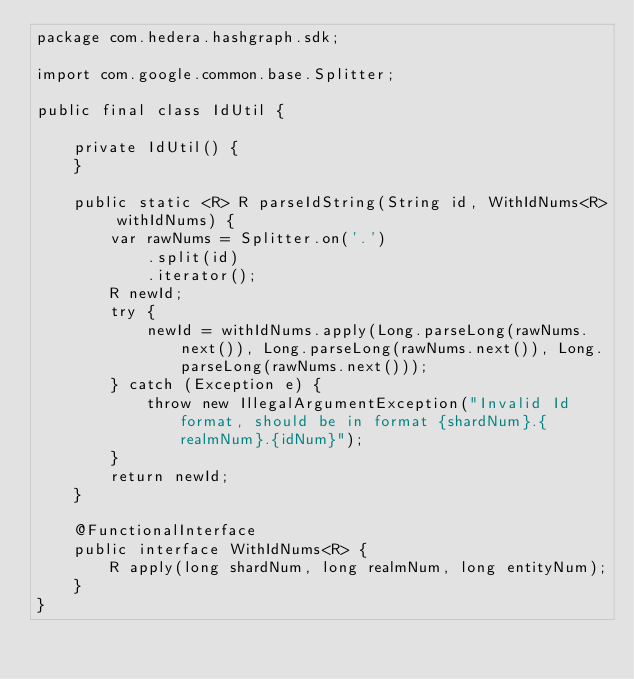Convert code to text. <code><loc_0><loc_0><loc_500><loc_500><_Java_>package com.hedera.hashgraph.sdk;

import com.google.common.base.Splitter;

public final class IdUtil {

    private IdUtil() {
    }

    public static <R> R parseIdString(String id, WithIdNums<R> withIdNums) {
        var rawNums = Splitter.on('.')
            .split(id)
            .iterator();
        R newId;
        try {
            newId = withIdNums.apply(Long.parseLong(rawNums.next()), Long.parseLong(rawNums.next()), Long.parseLong(rawNums.next()));
        } catch (Exception e) {
            throw new IllegalArgumentException("Invalid Id format, should be in format {shardNum}.{realmNum}.{idNum}");
        }
        return newId;
    }

    @FunctionalInterface
    public interface WithIdNums<R> {
        R apply(long shardNum, long realmNum, long entityNum);
    }
}
</code> 